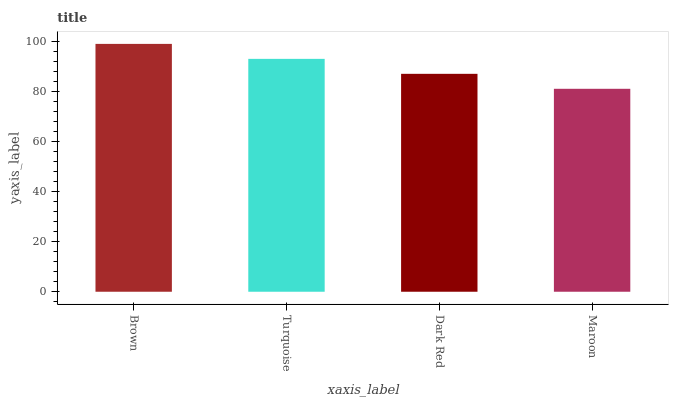Is Maroon the minimum?
Answer yes or no. Yes. Is Brown the maximum?
Answer yes or no. Yes. Is Turquoise the minimum?
Answer yes or no. No. Is Turquoise the maximum?
Answer yes or no. No. Is Brown greater than Turquoise?
Answer yes or no. Yes. Is Turquoise less than Brown?
Answer yes or no. Yes. Is Turquoise greater than Brown?
Answer yes or no. No. Is Brown less than Turquoise?
Answer yes or no. No. Is Turquoise the high median?
Answer yes or no. Yes. Is Dark Red the low median?
Answer yes or no. Yes. Is Maroon the high median?
Answer yes or no. No. Is Brown the low median?
Answer yes or no. No. 